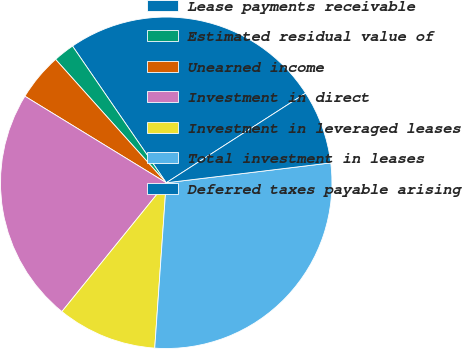<chart> <loc_0><loc_0><loc_500><loc_500><pie_chart><fcel>Lease payments receivable<fcel>Estimated residual value of<fcel>Unearned income<fcel>Investment in direct<fcel>Investment in leveraged leases<fcel>Total investment in leases<fcel>Deferred taxes payable arising<nl><fcel>25.47%<fcel>2.07%<fcel>4.62%<fcel>22.91%<fcel>9.73%<fcel>28.02%<fcel>7.18%<nl></chart> 